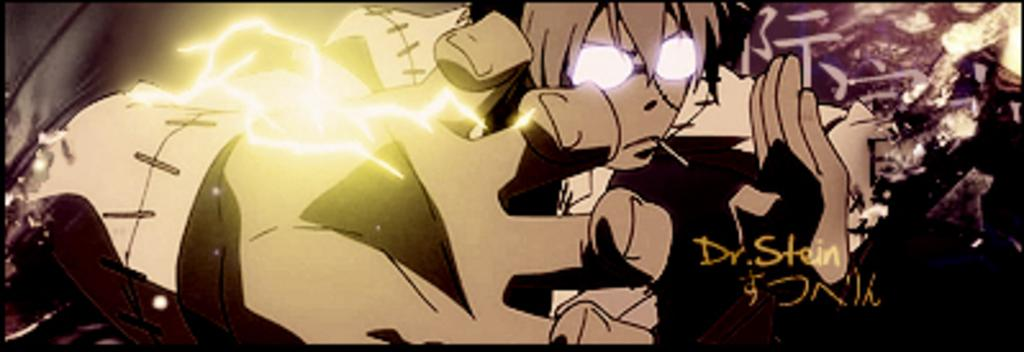What type of image is present in the picture? There is a cartoon picture in the image. Where is the text located in the image? The text is on the right side of the image. What type of juice can be seen being poured in the image? There is no juice present in the image. What type of lace is visible on the cartoon character in the image? There is no lace present in the image. What type of hose is connected to the cartoon character in the image? There is no hose connected to the cartoon character in the image. 